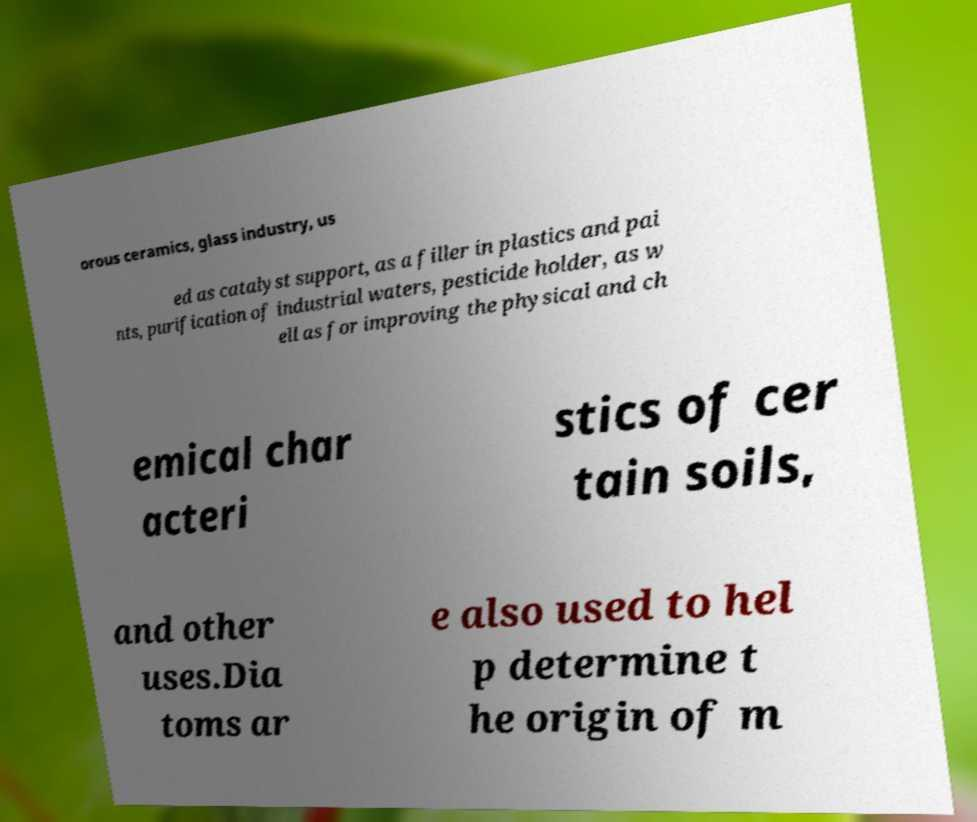I need the written content from this picture converted into text. Can you do that? orous ceramics, glass industry, us ed as catalyst support, as a filler in plastics and pai nts, purification of industrial waters, pesticide holder, as w ell as for improving the physical and ch emical char acteri stics of cer tain soils, and other uses.Dia toms ar e also used to hel p determine t he origin of m 